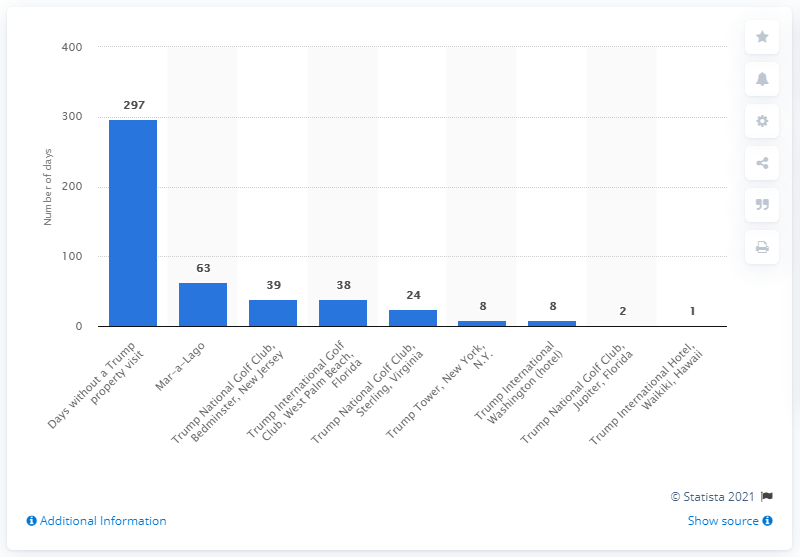List a handful of essential elements in this visual. Donald Trump has visited a specific restaurant, Mar-a-Lago, 63 times since his inauguration as President of the United States. 